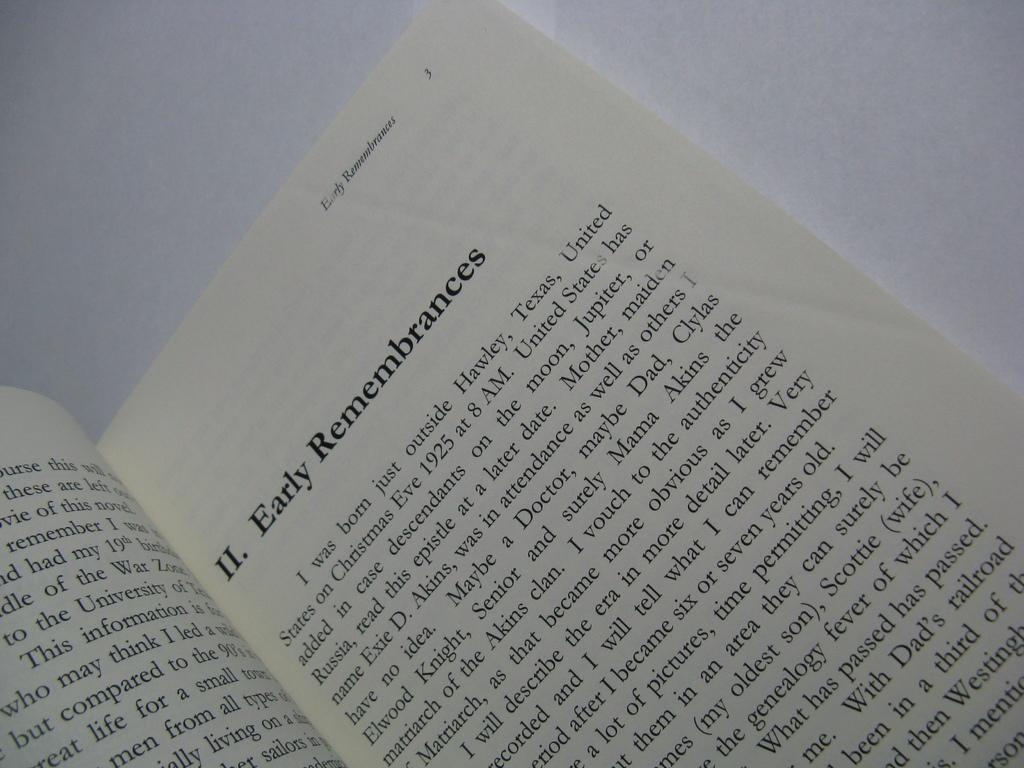<image>
Share a concise interpretation of the image provided. The second chapter of a book, called early remembrances 